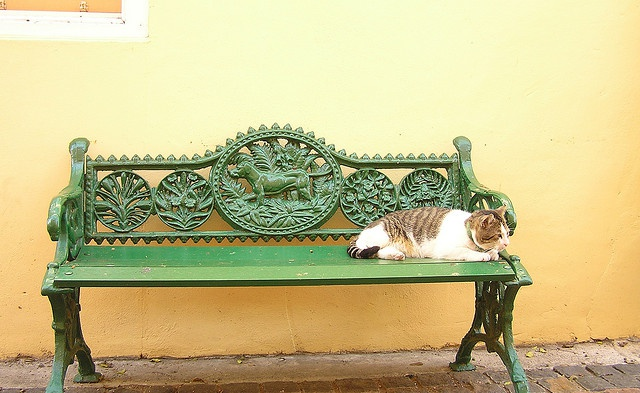Describe the objects in this image and their specific colors. I can see bench in tan, green, black, khaki, and olive tones and cat in tan and ivory tones in this image. 